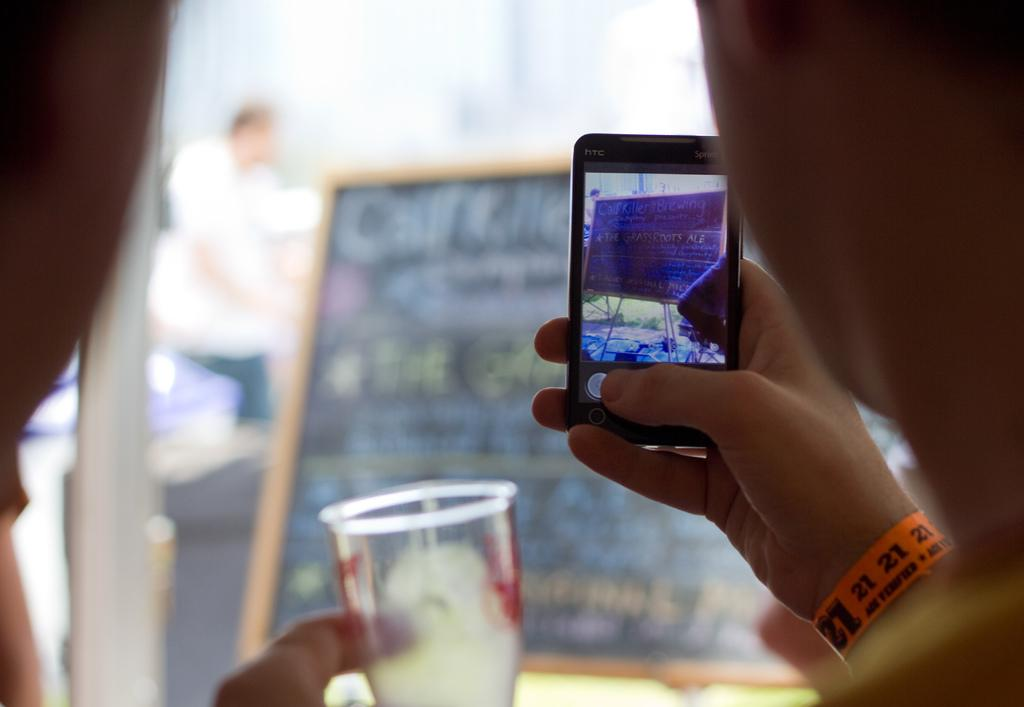Provide a one-sentence caption for the provided image. Person wearing an orange wristband that says the number 21 on it. 